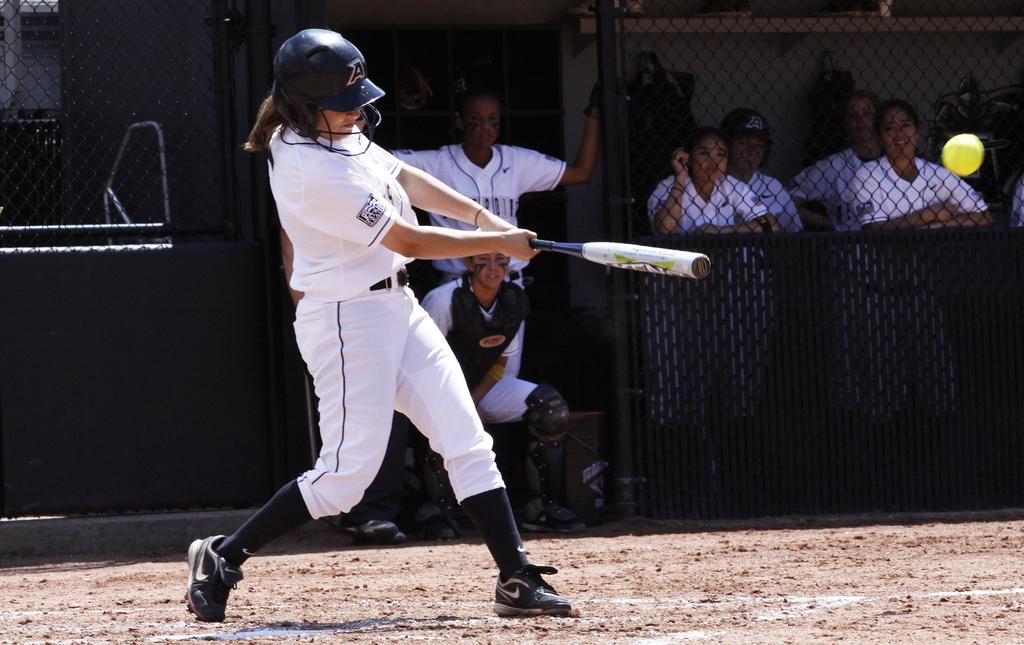Provide a one-sentence caption for the provided image. Baseball player wearing a helmet that has the letter A on it. 